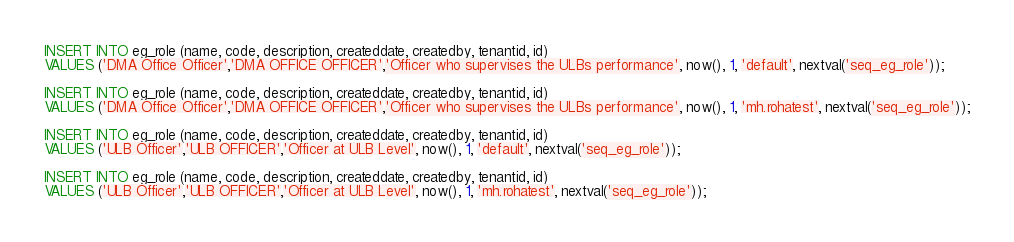<code> <loc_0><loc_0><loc_500><loc_500><_SQL_>INSERT INTO eg_role (name, code, description, createddate, createdby, tenantid, id) 
VALUES ('DMA Office Officer','DMA OFFICE OFFICER','Officer who supervises the ULBs performance', now(), 1, 'default', nextval('seq_eg_role'));

INSERT INTO eg_role (name, code, description, createddate, createdby, tenantid, id) 
VALUES ('DMA Office Officer','DMA OFFICE OFFICER','Officer who supervises the ULBs performance', now(), 1, 'mh.rohatest', nextval('seq_eg_role'));

INSERT INTO eg_role (name, code, description, createddate, createdby, tenantid, id) 
VALUES ('ULB Officer','ULB OFFICER','Officer at ULB Level', now(), 1, 'default', nextval('seq_eg_role'));

INSERT INTO eg_role (name, code, description, createddate, createdby, tenantid, id) 
VALUES ('ULB Officer','ULB OFFICER','Officer at ULB Level', now(), 1, 'mh.rohatest', nextval('seq_eg_role'));</code> 